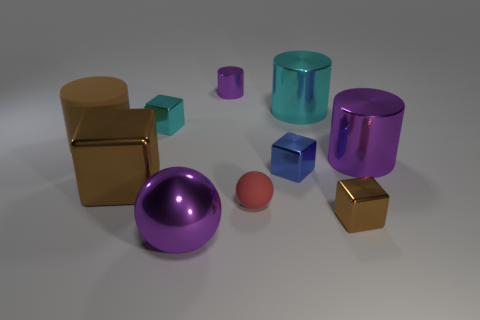The rubber thing in front of the brown object that is behind the purple metallic cylinder in front of the large matte cylinder is what shape?
Provide a short and direct response. Sphere. What is the shape of the tiny metal thing that is the same color as the shiny sphere?
Keep it short and to the point. Cylinder. Is there a brown sphere?
Offer a very short reply. No. Do the red matte thing and the cyan metallic cylinder behind the blue metal block have the same size?
Keep it short and to the point. No. Are there any large objects on the left side of the tiny shiny object behind the small cyan shiny object?
Keep it short and to the point. Yes. What is the material of the cylinder that is both in front of the cyan block and to the left of the tiny matte thing?
Give a very brief answer. Rubber. The cylinder that is in front of the large cylinder that is left of the purple shiny cylinder that is left of the small blue block is what color?
Offer a very short reply. Purple. The rubber cylinder that is the same size as the purple metal ball is what color?
Your answer should be compact. Brown. Is the color of the big rubber object the same as the metallic thing that is on the left side of the cyan shiny cube?
Keep it short and to the point. Yes. What is the material of the large brown object that is behind the purple cylinder that is to the right of the big cyan thing?
Offer a terse response. Rubber. 